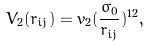Convert formula to latex. <formula><loc_0><loc_0><loc_500><loc_500>V _ { 2 } ( r _ { i j } ) = v _ { 2 } ( \frac { \sigma _ { 0 } } { r _ { i j } } ) ^ { 1 2 } ,</formula> 